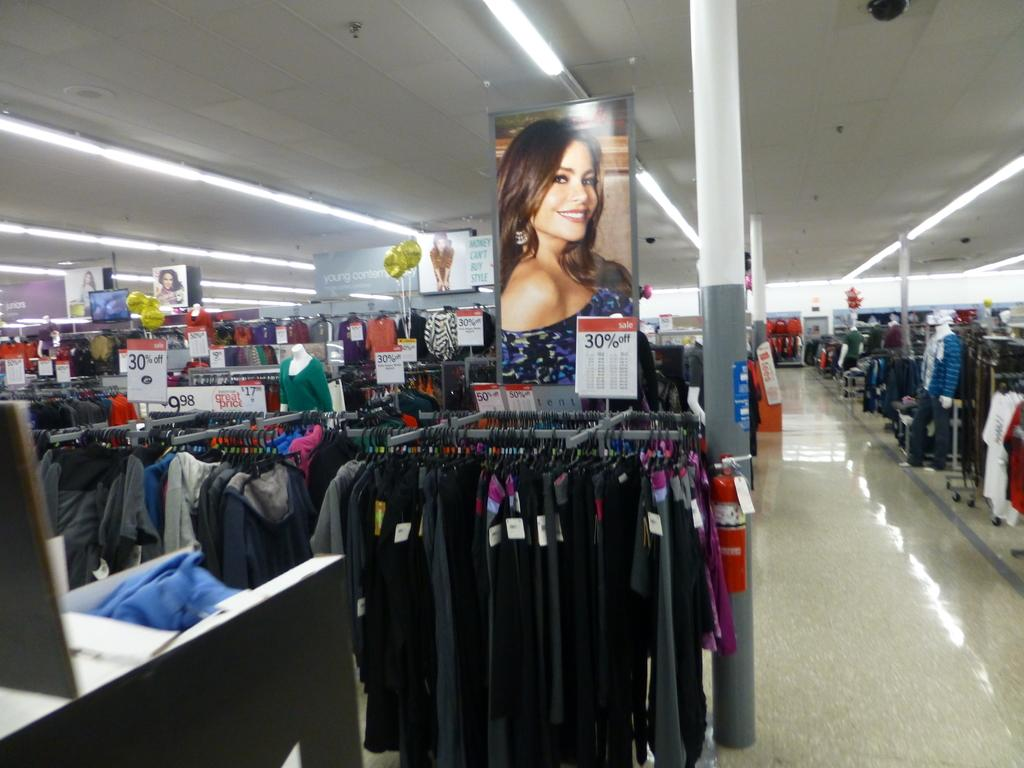What is hanging from the poles in the image? Clothes are hanging from hangers in the image. What can be seen in the middle of the image? There are poles in the middle of the image. What type of decorations are present in the image? There are posters in the image. What is providing illumination in the image? Lights are visible in the image. Can you see a plough being used in the image? There is no plough present in the image. What type of vase is placed on the table in the image? There is no vase present in the image. 